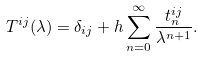<formula> <loc_0><loc_0><loc_500><loc_500>T ^ { i j } ( \lambda ) = \delta _ { i j } + h \sum _ { n = 0 } ^ { \infty } \frac { t _ { n } ^ { i j } } { \lambda ^ { n + 1 } } .</formula> 